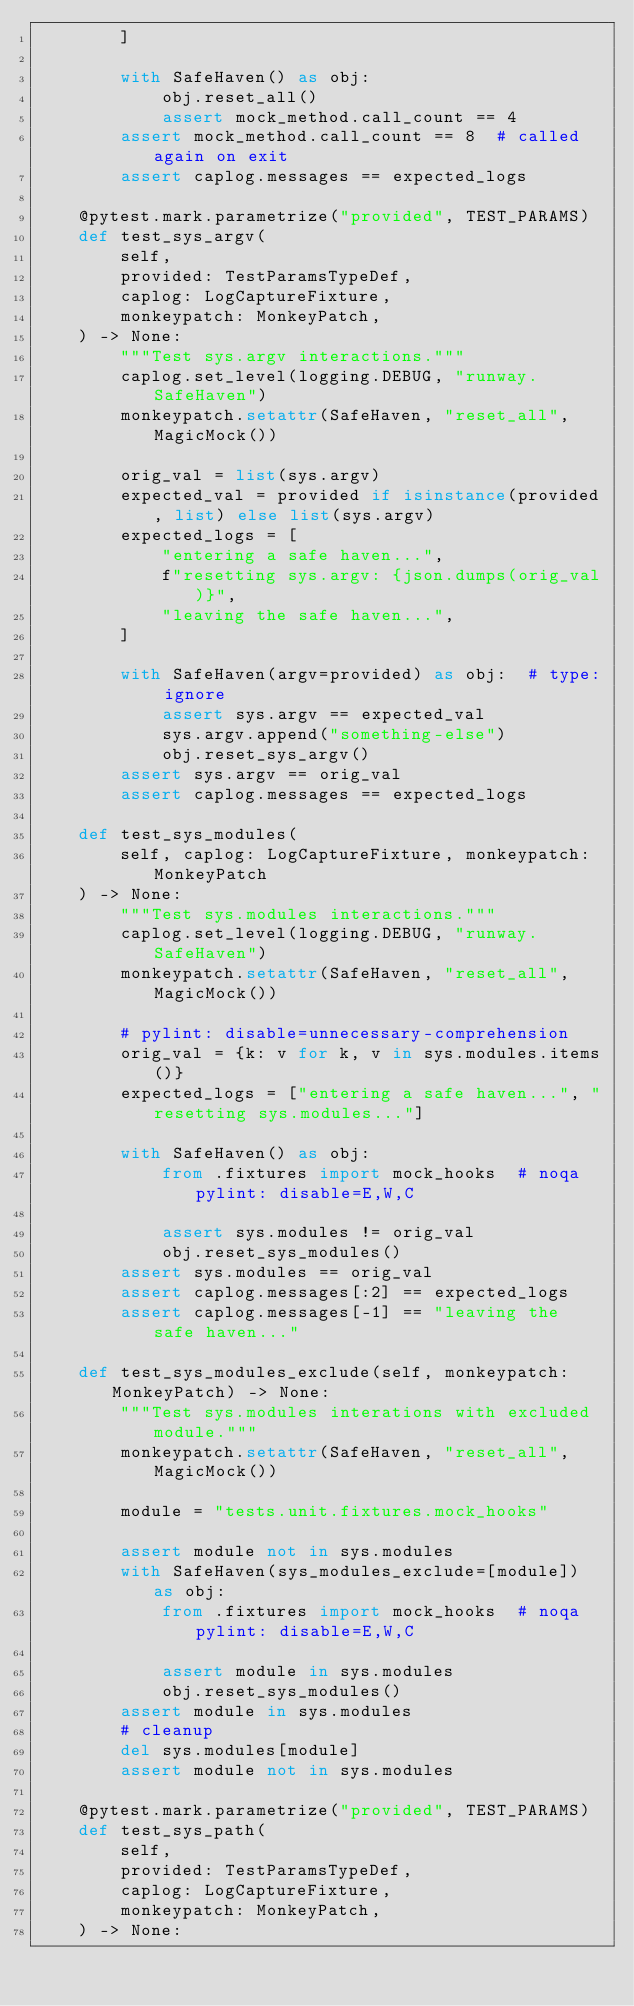<code> <loc_0><loc_0><loc_500><loc_500><_Python_>        ]

        with SafeHaven() as obj:
            obj.reset_all()
            assert mock_method.call_count == 4
        assert mock_method.call_count == 8  # called again on exit
        assert caplog.messages == expected_logs

    @pytest.mark.parametrize("provided", TEST_PARAMS)
    def test_sys_argv(
        self,
        provided: TestParamsTypeDef,
        caplog: LogCaptureFixture,
        monkeypatch: MonkeyPatch,
    ) -> None:
        """Test sys.argv interactions."""
        caplog.set_level(logging.DEBUG, "runway.SafeHaven")
        monkeypatch.setattr(SafeHaven, "reset_all", MagicMock())

        orig_val = list(sys.argv)
        expected_val = provided if isinstance(provided, list) else list(sys.argv)
        expected_logs = [
            "entering a safe haven...",
            f"resetting sys.argv: {json.dumps(orig_val)}",
            "leaving the safe haven...",
        ]

        with SafeHaven(argv=provided) as obj:  # type: ignore
            assert sys.argv == expected_val
            sys.argv.append("something-else")
            obj.reset_sys_argv()
        assert sys.argv == orig_val
        assert caplog.messages == expected_logs

    def test_sys_modules(
        self, caplog: LogCaptureFixture, monkeypatch: MonkeyPatch
    ) -> None:
        """Test sys.modules interactions."""
        caplog.set_level(logging.DEBUG, "runway.SafeHaven")
        monkeypatch.setattr(SafeHaven, "reset_all", MagicMock())

        # pylint: disable=unnecessary-comprehension
        orig_val = {k: v for k, v in sys.modules.items()}
        expected_logs = ["entering a safe haven...", "resetting sys.modules..."]

        with SafeHaven() as obj:
            from .fixtures import mock_hooks  # noqa pylint: disable=E,W,C

            assert sys.modules != orig_val
            obj.reset_sys_modules()
        assert sys.modules == orig_val
        assert caplog.messages[:2] == expected_logs
        assert caplog.messages[-1] == "leaving the safe haven..."

    def test_sys_modules_exclude(self, monkeypatch: MonkeyPatch) -> None:
        """Test sys.modules interations with excluded module."""
        monkeypatch.setattr(SafeHaven, "reset_all", MagicMock())

        module = "tests.unit.fixtures.mock_hooks"

        assert module not in sys.modules
        with SafeHaven(sys_modules_exclude=[module]) as obj:
            from .fixtures import mock_hooks  # noqa pylint: disable=E,W,C

            assert module in sys.modules
            obj.reset_sys_modules()
        assert module in sys.modules
        # cleanup
        del sys.modules[module]
        assert module not in sys.modules

    @pytest.mark.parametrize("provided", TEST_PARAMS)
    def test_sys_path(
        self,
        provided: TestParamsTypeDef,
        caplog: LogCaptureFixture,
        monkeypatch: MonkeyPatch,
    ) -> None:</code> 